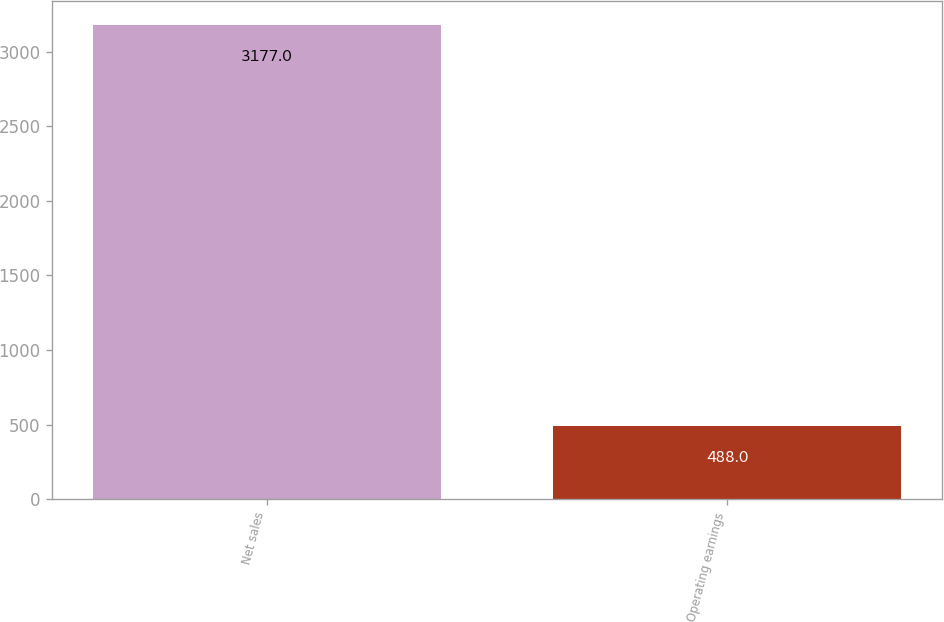Convert chart. <chart><loc_0><loc_0><loc_500><loc_500><bar_chart><fcel>Net sales<fcel>Operating earnings<nl><fcel>3177<fcel>488<nl></chart> 